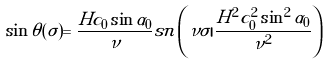Convert formula to latex. <formula><loc_0><loc_0><loc_500><loc_500>\sin \theta ( \sigma ) = \frac { H c _ { 0 } \sin \alpha _ { 0 } } { \nu } { s n } \left ( \nu \sigma | \frac { H ^ { 2 } c _ { 0 } ^ { 2 } \sin ^ { 2 } \alpha _ { 0 } } { \nu ^ { 2 } } \right )</formula> 